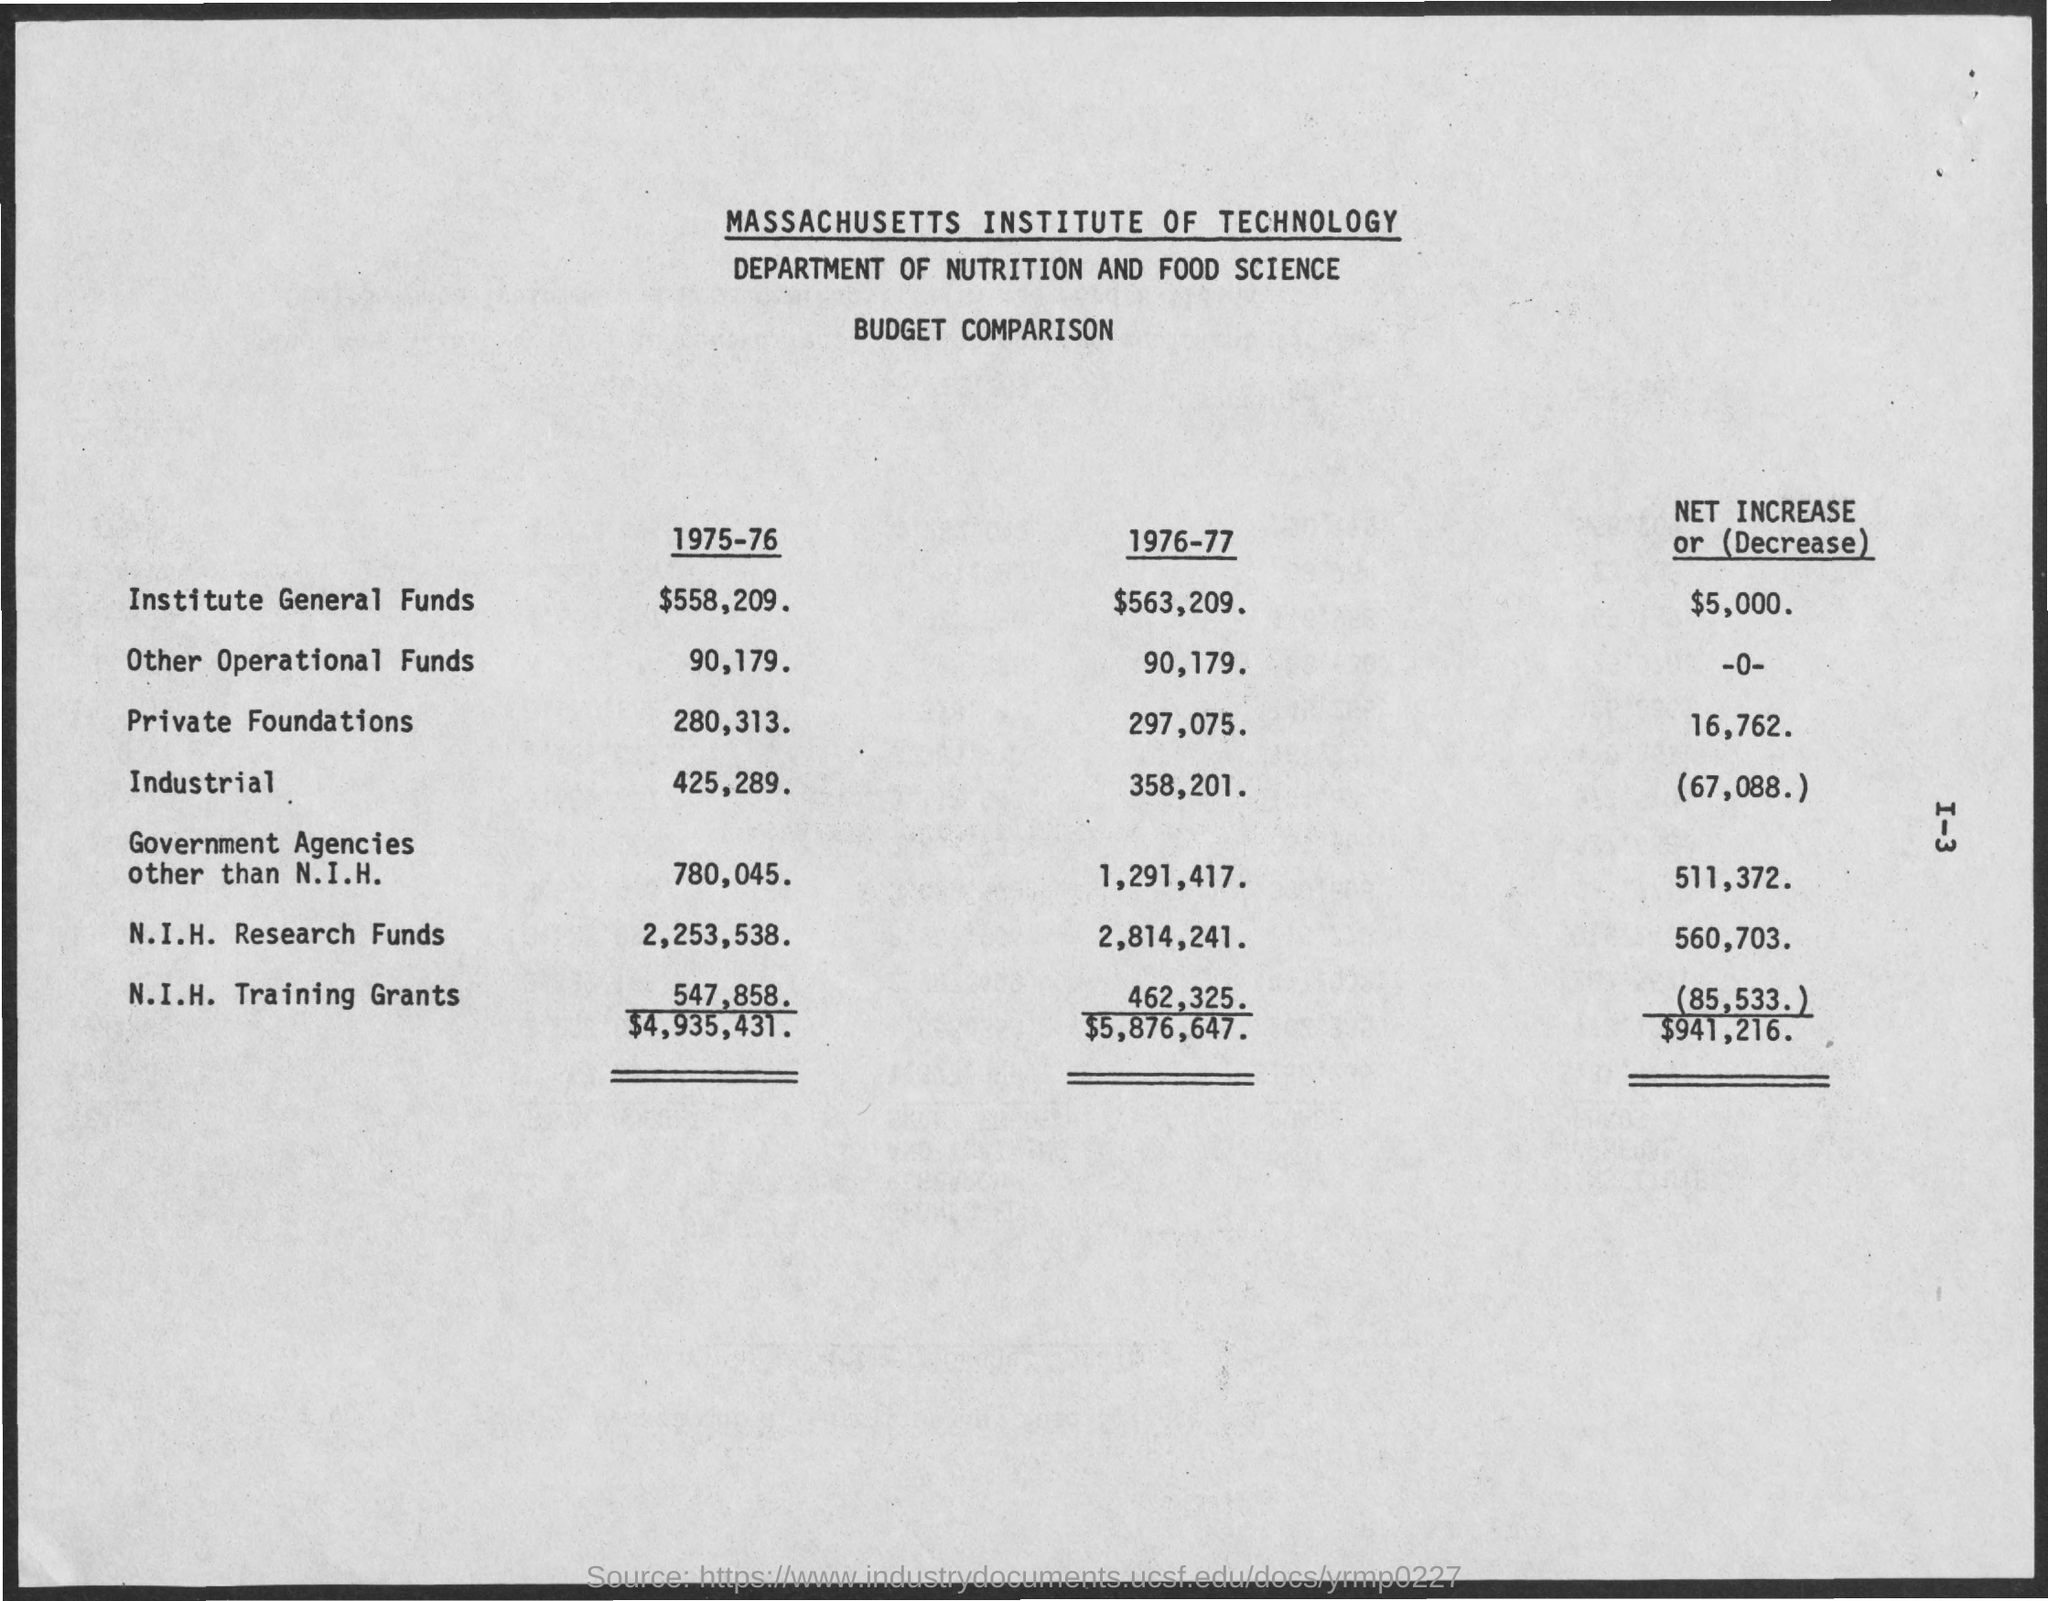What is the Institute General Funds for 1975-76?
Your response must be concise. $558,209. What is the Institute General Funds for 1976-77?
Your answer should be compact. $563,209. What is the Other Operational Funds for 1975-76?
Your answer should be very brief. 90,179. What is the Other Operational Funds for 1976-77?
Your response must be concise. 90,179. What is the Private Foundations for 1975-76?
Offer a terse response. 280,313. What is the Private Foundations for 1976-77?
Your response must be concise. 297,075. What is the N.I.H. Research Funds for 1975-76?
Your answer should be very brief. 2,253,538. What is the N.I.H. Research Funds for 1976-77?
Offer a terse response. 2,814,241. What is the N.I.H. Training Grants for 1975-76?
Your answer should be very brief. 547,858. What is the N.I.H. Training Grants for 1976-77?
Give a very brief answer. 462,325. 